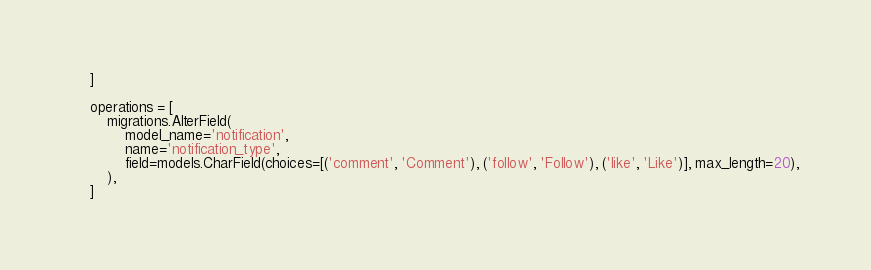Convert code to text. <code><loc_0><loc_0><loc_500><loc_500><_Python_>    ]

    operations = [
        migrations.AlterField(
            model_name='notification',
            name='notification_type',
            field=models.CharField(choices=[('comment', 'Comment'), ('follow', 'Follow'), ('like', 'Like')], max_length=20),
        ),
    ]
</code> 